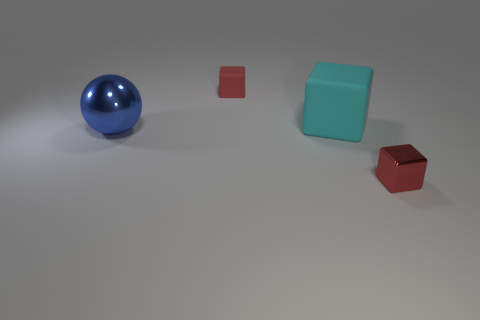Are there any other things that have the same shape as the red rubber thing?
Your response must be concise. Yes. Are there more brown rubber blocks than large shiny things?
Your answer should be very brief. No. How many things are on the left side of the red rubber object and in front of the large blue metal sphere?
Give a very brief answer. 0. What number of tiny matte objects are right of the red object that is behind the big metal ball?
Offer a terse response. 0. There is a object that is on the left side of the red matte object; is it the same size as the red cube that is to the left of the large rubber thing?
Keep it short and to the point. No. How many tiny things are there?
Provide a succinct answer. 2. What number of tiny red things have the same material as the large cyan block?
Ensure brevity in your answer.  1. Is the number of cyan objects that are on the left side of the cyan matte thing the same as the number of cyan blocks?
Give a very brief answer. No. What is the material of the other small cube that is the same color as the tiny matte block?
Provide a short and direct response. Metal. There is a ball; is it the same size as the red thing that is behind the blue ball?
Your answer should be compact. No. 